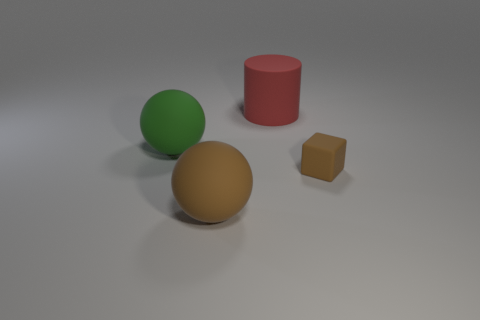Add 2 cylinders. How many objects exist? 6 Subtract all cylinders. How many objects are left? 3 Add 2 rubber objects. How many rubber objects exist? 6 Subtract 0 yellow cylinders. How many objects are left? 4 Subtract all large red matte cylinders. Subtract all large red rubber things. How many objects are left? 2 Add 1 brown blocks. How many brown blocks are left? 2 